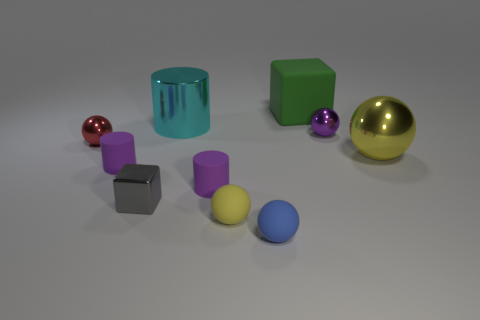Subtract 2 spheres. How many spheres are left? 3 Subtract all red balls. How many balls are left? 4 Subtract all small blue balls. How many balls are left? 4 Subtract all brown balls. Subtract all gray blocks. How many balls are left? 5 Subtract all cubes. How many objects are left? 8 Add 6 metal cylinders. How many metal cylinders exist? 7 Subtract 0 red cubes. How many objects are left? 10 Subtract all big gray metallic cylinders. Subtract all rubber things. How many objects are left? 5 Add 2 small matte cylinders. How many small matte cylinders are left? 4 